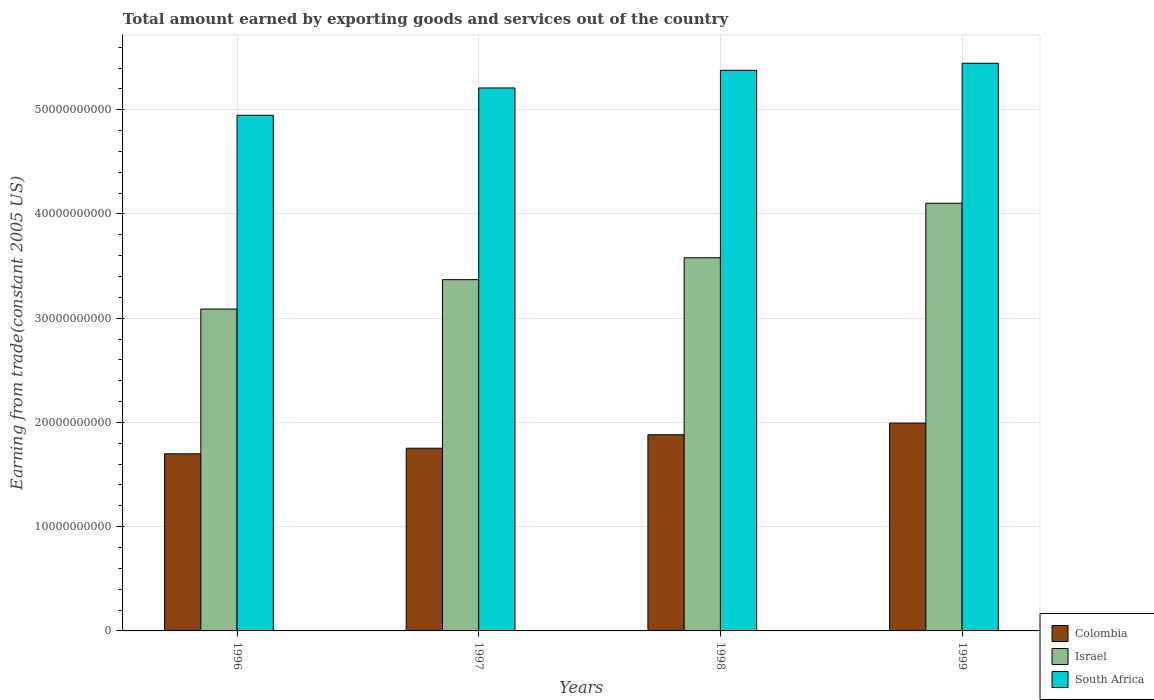How many different coloured bars are there?
Make the answer very short. 3. How many groups of bars are there?
Offer a very short reply. 4. Are the number of bars per tick equal to the number of legend labels?
Provide a succinct answer. Yes. Are the number of bars on each tick of the X-axis equal?
Provide a succinct answer. Yes. How many bars are there on the 3rd tick from the left?
Keep it short and to the point. 3. How many bars are there on the 4th tick from the right?
Give a very brief answer. 3. What is the label of the 2nd group of bars from the left?
Ensure brevity in your answer.  1997. What is the total amount earned by exporting goods and services in Colombia in 1999?
Offer a terse response. 1.99e+1. Across all years, what is the maximum total amount earned by exporting goods and services in Colombia?
Keep it short and to the point. 1.99e+1. Across all years, what is the minimum total amount earned by exporting goods and services in South Africa?
Your response must be concise. 4.95e+1. What is the total total amount earned by exporting goods and services in Colombia in the graph?
Offer a terse response. 7.33e+1. What is the difference between the total amount earned by exporting goods and services in Colombia in 1996 and that in 1997?
Ensure brevity in your answer.  -5.36e+08. What is the difference between the total amount earned by exporting goods and services in South Africa in 1998 and the total amount earned by exporting goods and services in Colombia in 1997?
Your response must be concise. 3.63e+1. What is the average total amount earned by exporting goods and services in Colombia per year?
Provide a succinct answer. 1.83e+1. In the year 1997, what is the difference between the total amount earned by exporting goods and services in Colombia and total amount earned by exporting goods and services in Israel?
Offer a very short reply. -1.62e+1. What is the ratio of the total amount earned by exporting goods and services in Colombia in 1996 to that in 1998?
Keep it short and to the point. 0.9. Is the difference between the total amount earned by exporting goods and services in Colombia in 1997 and 1998 greater than the difference between the total amount earned by exporting goods and services in Israel in 1997 and 1998?
Make the answer very short. Yes. What is the difference between the highest and the second highest total amount earned by exporting goods and services in Colombia?
Give a very brief answer. 1.11e+09. What is the difference between the highest and the lowest total amount earned by exporting goods and services in South Africa?
Your answer should be very brief. 4.99e+09. In how many years, is the total amount earned by exporting goods and services in South Africa greater than the average total amount earned by exporting goods and services in South Africa taken over all years?
Your answer should be compact. 2. What does the 1st bar from the right in 1999 represents?
Your answer should be very brief. South Africa. How many bars are there?
Offer a very short reply. 12. Are all the bars in the graph horizontal?
Offer a terse response. No. How many years are there in the graph?
Your answer should be very brief. 4. What is the difference between two consecutive major ticks on the Y-axis?
Your answer should be very brief. 1.00e+1. Does the graph contain grids?
Offer a terse response. Yes. How many legend labels are there?
Offer a very short reply. 3. How are the legend labels stacked?
Your answer should be compact. Vertical. What is the title of the graph?
Ensure brevity in your answer.  Total amount earned by exporting goods and services out of the country. Does "St. Martin (French part)" appear as one of the legend labels in the graph?
Provide a short and direct response. No. What is the label or title of the Y-axis?
Offer a very short reply. Earning from trade(constant 2005 US). What is the Earning from trade(constant 2005 US) of Colombia in 1996?
Offer a very short reply. 1.70e+1. What is the Earning from trade(constant 2005 US) in Israel in 1996?
Provide a succinct answer. 3.09e+1. What is the Earning from trade(constant 2005 US) in South Africa in 1996?
Give a very brief answer. 4.95e+1. What is the Earning from trade(constant 2005 US) of Colombia in 1997?
Your answer should be very brief. 1.75e+1. What is the Earning from trade(constant 2005 US) in Israel in 1997?
Keep it short and to the point. 3.37e+1. What is the Earning from trade(constant 2005 US) in South Africa in 1997?
Your answer should be compact. 5.21e+1. What is the Earning from trade(constant 2005 US) in Colombia in 1998?
Make the answer very short. 1.88e+1. What is the Earning from trade(constant 2005 US) of Israel in 1998?
Your answer should be compact. 3.58e+1. What is the Earning from trade(constant 2005 US) of South Africa in 1998?
Offer a terse response. 5.38e+1. What is the Earning from trade(constant 2005 US) of Colombia in 1999?
Ensure brevity in your answer.  1.99e+1. What is the Earning from trade(constant 2005 US) in Israel in 1999?
Provide a succinct answer. 4.10e+1. What is the Earning from trade(constant 2005 US) in South Africa in 1999?
Give a very brief answer. 5.45e+1. Across all years, what is the maximum Earning from trade(constant 2005 US) in Colombia?
Keep it short and to the point. 1.99e+1. Across all years, what is the maximum Earning from trade(constant 2005 US) in Israel?
Your answer should be compact. 4.10e+1. Across all years, what is the maximum Earning from trade(constant 2005 US) of South Africa?
Make the answer very short. 5.45e+1. Across all years, what is the minimum Earning from trade(constant 2005 US) in Colombia?
Make the answer very short. 1.70e+1. Across all years, what is the minimum Earning from trade(constant 2005 US) of Israel?
Offer a very short reply. 3.09e+1. Across all years, what is the minimum Earning from trade(constant 2005 US) of South Africa?
Keep it short and to the point. 4.95e+1. What is the total Earning from trade(constant 2005 US) of Colombia in the graph?
Make the answer very short. 7.33e+1. What is the total Earning from trade(constant 2005 US) of Israel in the graph?
Give a very brief answer. 1.41e+11. What is the total Earning from trade(constant 2005 US) in South Africa in the graph?
Offer a very short reply. 2.10e+11. What is the difference between the Earning from trade(constant 2005 US) in Colombia in 1996 and that in 1997?
Your answer should be compact. -5.36e+08. What is the difference between the Earning from trade(constant 2005 US) of Israel in 1996 and that in 1997?
Your answer should be compact. -2.82e+09. What is the difference between the Earning from trade(constant 2005 US) of South Africa in 1996 and that in 1997?
Offer a very short reply. -2.62e+09. What is the difference between the Earning from trade(constant 2005 US) in Colombia in 1996 and that in 1998?
Your answer should be very brief. -1.83e+09. What is the difference between the Earning from trade(constant 2005 US) in Israel in 1996 and that in 1998?
Make the answer very short. -4.92e+09. What is the difference between the Earning from trade(constant 2005 US) of South Africa in 1996 and that in 1998?
Your answer should be compact. -4.31e+09. What is the difference between the Earning from trade(constant 2005 US) of Colombia in 1996 and that in 1999?
Provide a short and direct response. -2.94e+09. What is the difference between the Earning from trade(constant 2005 US) in Israel in 1996 and that in 1999?
Offer a very short reply. -1.02e+1. What is the difference between the Earning from trade(constant 2005 US) in South Africa in 1996 and that in 1999?
Offer a terse response. -4.99e+09. What is the difference between the Earning from trade(constant 2005 US) in Colombia in 1997 and that in 1998?
Offer a terse response. -1.29e+09. What is the difference between the Earning from trade(constant 2005 US) in Israel in 1997 and that in 1998?
Give a very brief answer. -2.10e+09. What is the difference between the Earning from trade(constant 2005 US) in South Africa in 1997 and that in 1998?
Keep it short and to the point. -1.69e+09. What is the difference between the Earning from trade(constant 2005 US) of Colombia in 1997 and that in 1999?
Your response must be concise. -2.41e+09. What is the difference between the Earning from trade(constant 2005 US) of Israel in 1997 and that in 1999?
Make the answer very short. -7.33e+09. What is the difference between the Earning from trade(constant 2005 US) in South Africa in 1997 and that in 1999?
Ensure brevity in your answer.  -2.37e+09. What is the difference between the Earning from trade(constant 2005 US) of Colombia in 1998 and that in 1999?
Your answer should be compact. -1.11e+09. What is the difference between the Earning from trade(constant 2005 US) in Israel in 1998 and that in 1999?
Keep it short and to the point. -5.23e+09. What is the difference between the Earning from trade(constant 2005 US) in South Africa in 1998 and that in 1999?
Offer a very short reply. -6.78e+08. What is the difference between the Earning from trade(constant 2005 US) of Colombia in 1996 and the Earning from trade(constant 2005 US) of Israel in 1997?
Give a very brief answer. -1.67e+1. What is the difference between the Earning from trade(constant 2005 US) in Colombia in 1996 and the Earning from trade(constant 2005 US) in South Africa in 1997?
Your answer should be very brief. -3.51e+1. What is the difference between the Earning from trade(constant 2005 US) in Israel in 1996 and the Earning from trade(constant 2005 US) in South Africa in 1997?
Give a very brief answer. -2.12e+1. What is the difference between the Earning from trade(constant 2005 US) in Colombia in 1996 and the Earning from trade(constant 2005 US) in Israel in 1998?
Your answer should be compact. -1.88e+1. What is the difference between the Earning from trade(constant 2005 US) of Colombia in 1996 and the Earning from trade(constant 2005 US) of South Africa in 1998?
Ensure brevity in your answer.  -3.68e+1. What is the difference between the Earning from trade(constant 2005 US) in Israel in 1996 and the Earning from trade(constant 2005 US) in South Africa in 1998?
Ensure brevity in your answer.  -2.29e+1. What is the difference between the Earning from trade(constant 2005 US) in Colombia in 1996 and the Earning from trade(constant 2005 US) in Israel in 1999?
Provide a short and direct response. -2.40e+1. What is the difference between the Earning from trade(constant 2005 US) in Colombia in 1996 and the Earning from trade(constant 2005 US) in South Africa in 1999?
Make the answer very short. -3.75e+1. What is the difference between the Earning from trade(constant 2005 US) in Israel in 1996 and the Earning from trade(constant 2005 US) in South Africa in 1999?
Your response must be concise. -2.36e+1. What is the difference between the Earning from trade(constant 2005 US) of Colombia in 1997 and the Earning from trade(constant 2005 US) of Israel in 1998?
Make the answer very short. -1.83e+1. What is the difference between the Earning from trade(constant 2005 US) in Colombia in 1997 and the Earning from trade(constant 2005 US) in South Africa in 1998?
Your answer should be compact. -3.63e+1. What is the difference between the Earning from trade(constant 2005 US) in Israel in 1997 and the Earning from trade(constant 2005 US) in South Africa in 1998?
Your response must be concise. -2.01e+1. What is the difference between the Earning from trade(constant 2005 US) of Colombia in 1997 and the Earning from trade(constant 2005 US) of Israel in 1999?
Ensure brevity in your answer.  -2.35e+1. What is the difference between the Earning from trade(constant 2005 US) of Colombia in 1997 and the Earning from trade(constant 2005 US) of South Africa in 1999?
Provide a short and direct response. -3.69e+1. What is the difference between the Earning from trade(constant 2005 US) in Israel in 1997 and the Earning from trade(constant 2005 US) in South Africa in 1999?
Offer a terse response. -2.08e+1. What is the difference between the Earning from trade(constant 2005 US) in Colombia in 1998 and the Earning from trade(constant 2005 US) in Israel in 1999?
Provide a succinct answer. -2.22e+1. What is the difference between the Earning from trade(constant 2005 US) in Colombia in 1998 and the Earning from trade(constant 2005 US) in South Africa in 1999?
Make the answer very short. -3.56e+1. What is the difference between the Earning from trade(constant 2005 US) of Israel in 1998 and the Earning from trade(constant 2005 US) of South Africa in 1999?
Offer a terse response. -1.87e+1. What is the average Earning from trade(constant 2005 US) in Colombia per year?
Offer a very short reply. 1.83e+1. What is the average Earning from trade(constant 2005 US) in Israel per year?
Offer a very short reply. 3.54e+1. What is the average Earning from trade(constant 2005 US) in South Africa per year?
Provide a short and direct response. 5.24e+1. In the year 1996, what is the difference between the Earning from trade(constant 2005 US) in Colombia and Earning from trade(constant 2005 US) in Israel?
Your answer should be very brief. -1.39e+1. In the year 1996, what is the difference between the Earning from trade(constant 2005 US) of Colombia and Earning from trade(constant 2005 US) of South Africa?
Keep it short and to the point. -3.25e+1. In the year 1996, what is the difference between the Earning from trade(constant 2005 US) of Israel and Earning from trade(constant 2005 US) of South Africa?
Provide a succinct answer. -1.86e+1. In the year 1997, what is the difference between the Earning from trade(constant 2005 US) in Colombia and Earning from trade(constant 2005 US) in Israel?
Ensure brevity in your answer.  -1.62e+1. In the year 1997, what is the difference between the Earning from trade(constant 2005 US) in Colombia and Earning from trade(constant 2005 US) in South Africa?
Offer a terse response. -3.46e+1. In the year 1997, what is the difference between the Earning from trade(constant 2005 US) of Israel and Earning from trade(constant 2005 US) of South Africa?
Keep it short and to the point. -1.84e+1. In the year 1998, what is the difference between the Earning from trade(constant 2005 US) of Colombia and Earning from trade(constant 2005 US) of Israel?
Ensure brevity in your answer.  -1.70e+1. In the year 1998, what is the difference between the Earning from trade(constant 2005 US) in Colombia and Earning from trade(constant 2005 US) in South Africa?
Your response must be concise. -3.50e+1. In the year 1998, what is the difference between the Earning from trade(constant 2005 US) of Israel and Earning from trade(constant 2005 US) of South Africa?
Make the answer very short. -1.80e+1. In the year 1999, what is the difference between the Earning from trade(constant 2005 US) in Colombia and Earning from trade(constant 2005 US) in Israel?
Provide a succinct answer. -2.11e+1. In the year 1999, what is the difference between the Earning from trade(constant 2005 US) of Colombia and Earning from trade(constant 2005 US) of South Africa?
Keep it short and to the point. -3.45e+1. In the year 1999, what is the difference between the Earning from trade(constant 2005 US) in Israel and Earning from trade(constant 2005 US) in South Africa?
Offer a terse response. -1.34e+1. What is the ratio of the Earning from trade(constant 2005 US) of Colombia in 1996 to that in 1997?
Make the answer very short. 0.97. What is the ratio of the Earning from trade(constant 2005 US) of Israel in 1996 to that in 1997?
Offer a very short reply. 0.92. What is the ratio of the Earning from trade(constant 2005 US) of South Africa in 1996 to that in 1997?
Your response must be concise. 0.95. What is the ratio of the Earning from trade(constant 2005 US) in Colombia in 1996 to that in 1998?
Keep it short and to the point. 0.9. What is the ratio of the Earning from trade(constant 2005 US) of Israel in 1996 to that in 1998?
Offer a terse response. 0.86. What is the ratio of the Earning from trade(constant 2005 US) of South Africa in 1996 to that in 1998?
Offer a very short reply. 0.92. What is the ratio of the Earning from trade(constant 2005 US) in Colombia in 1996 to that in 1999?
Offer a very short reply. 0.85. What is the ratio of the Earning from trade(constant 2005 US) in Israel in 1996 to that in 1999?
Make the answer very short. 0.75. What is the ratio of the Earning from trade(constant 2005 US) of South Africa in 1996 to that in 1999?
Your response must be concise. 0.91. What is the ratio of the Earning from trade(constant 2005 US) in Colombia in 1997 to that in 1998?
Provide a succinct answer. 0.93. What is the ratio of the Earning from trade(constant 2005 US) in Israel in 1997 to that in 1998?
Make the answer very short. 0.94. What is the ratio of the Earning from trade(constant 2005 US) of South Africa in 1997 to that in 1998?
Your response must be concise. 0.97. What is the ratio of the Earning from trade(constant 2005 US) of Colombia in 1997 to that in 1999?
Your response must be concise. 0.88. What is the ratio of the Earning from trade(constant 2005 US) in Israel in 1997 to that in 1999?
Give a very brief answer. 0.82. What is the ratio of the Earning from trade(constant 2005 US) of South Africa in 1997 to that in 1999?
Your answer should be compact. 0.96. What is the ratio of the Earning from trade(constant 2005 US) of Colombia in 1998 to that in 1999?
Make the answer very short. 0.94. What is the ratio of the Earning from trade(constant 2005 US) of Israel in 1998 to that in 1999?
Your response must be concise. 0.87. What is the ratio of the Earning from trade(constant 2005 US) in South Africa in 1998 to that in 1999?
Offer a terse response. 0.99. What is the difference between the highest and the second highest Earning from trade(constant 2005 US) of Colombia?
Your response must be concise. 1.11e+09. What is the difference between the highest and the second highest Earning from trade(constant 2005 US) in Israel?
Your answer should be compact. 5.23e+09. What is the difference between the highest and the second highest Earning from trade(constant 2005 US) of South Africa?
Your answer should be compact. 6.78e+08. What is the difference between the highest and the lowest Earning from trade(constant 2005 US) of Colombia?
Your response must be concise. 2.94e+09. What is the difference between the highest and the lowest Earning from trade(constant 2005 US) in Israel?
Give a very brief answer. 1.02e+1. What is the difference between the highest and the lowest Earning from trade(constant 2005 US) in South Africa?
Offer a terse response. 4.99e+09. 